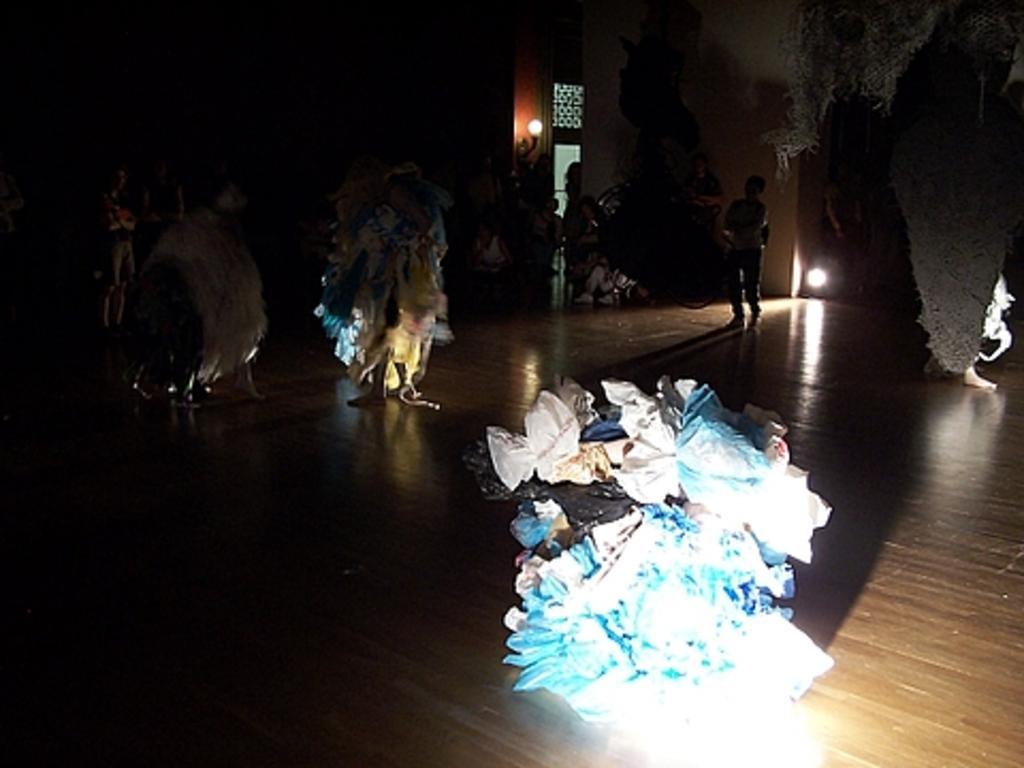Describe this image in one or two sentences. In this image I can see few colorful objects and few people standing on the brown color floor. Back I can see a light and the wall. 